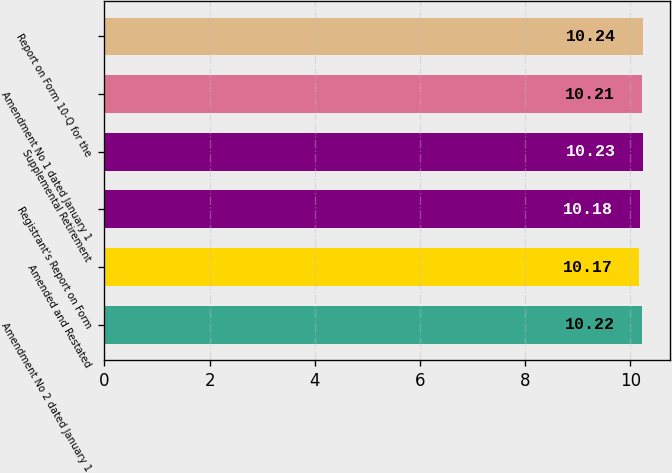Convert chart. <chart><loc_0><loc_0><loc_500><loc_500><bar_chart><fcel>Amendment No 2 dated January 1<fcel>Amended and Restated<fcel>Registrant's Report on Form<fcel>Supplemental Retirement<fcel>Amendment No 1 dated January 1<fcel>Report on Form 10-Q for the<nl><fcel>10.22<fcel>10.17<fcel>10.18<fcel>10.23<fcel>10.21<fcel>10.24<nl></chart> 